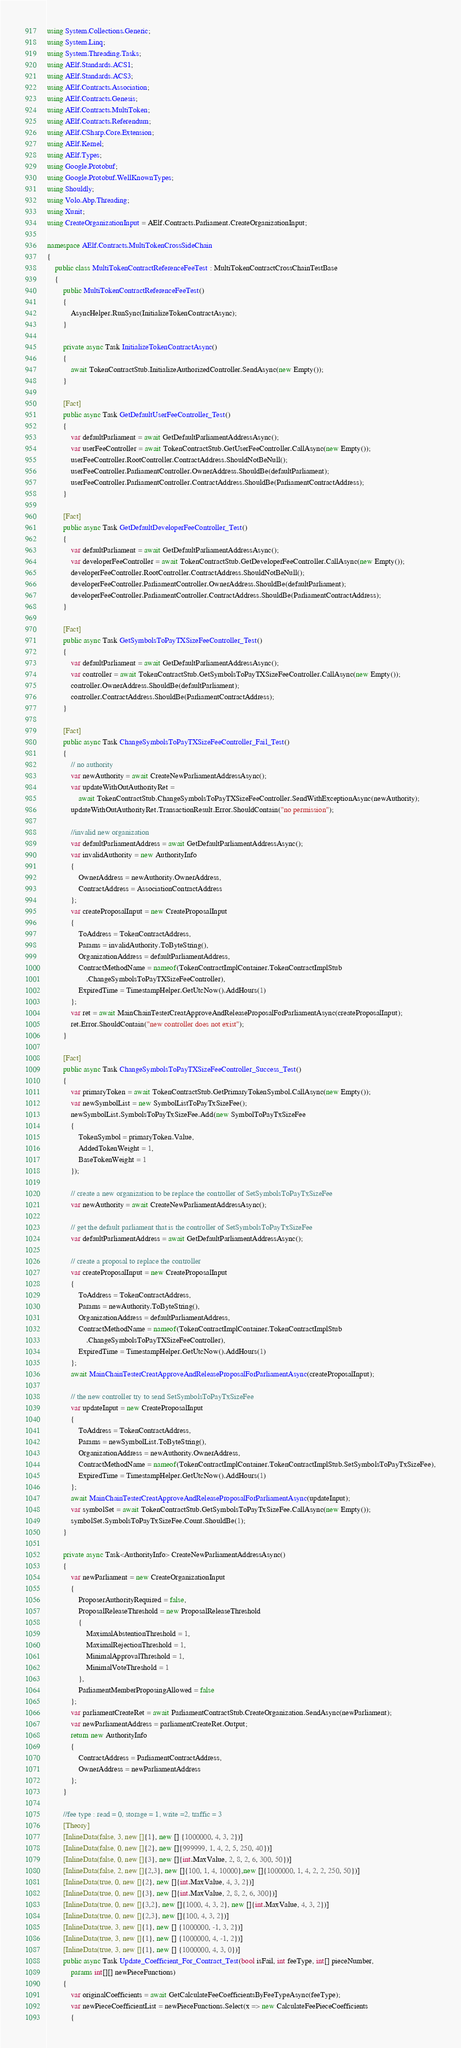Convert code to text. <code><loc_0><loc_0><loc_500><loc_500><_C#_>using System.Collections.Generic;
using System.Linq;
using System.Threading.Tasks;
using AElf.Standards.ACS1;
using AElf.Standards.ACS3;
using AElf.Contracts.Association;
using AElf.Contracts.Genesis;
using AElf.Contracts.MultiToken;
using AElf.Contracts.Referendum;
using AElf.CSharp.Core.Extension;
using AElf.Kernel;
using AElf.Types;
using Google.Protobuf;
using Google.Protobuf.WellKnownTypes;
using Shouldly;
using Volo.Abp.Threading;
using Xunit;
using CreateOrganizationInput = AElf.Contracts.Parliament.CreateOrganizationInput;

namespace AElf.Contracts.MultiTokenCrossSideChain
{
    public class MultiTokenContractReferenceFeeTest : MultiTokenContractCrossChainTestBase
    {
        public MultiTokenContractReferenceFeeTest()
        {
            AsyncHelper.RunSync(InitializeTokenContractAsync);
        }

        private async Task InitializeTokenContractAsync()
        {
            await TokenContractStub.InitializeAuthorizedController.SendAsync(new Empty());
        }
        
        [Fact]
        public async Task GetDefaultUserFeeController_Test()
        {
            var defaultParliament = await GetDefaultParliamentAddressAsync();
            var userFeeController = await TokenContractStub.GetUserFeeController.CallAsync(new Empty());
            userFeeController.RootController.ContractAddress.ShouldNotBeNull();
            userFeeController.ParliamentController.OwnerAddress.ShouldBe(defaultParliament);
            userFeeController.ParliamentController.ContractAddress.ShouldBe(ParliamentContractAddress);
        }
        
        [Fact]
        public async Task GetDefaultDeveloperFeeController_Test()
        {
            var defaultParliament = await GetDefaultParliamentAddressAsync();
            var developerFeeController = await TokenContractStub.GetDeveloperFeeController.CallAsync(new Empty());
            developerFeeController.RootController.ContractAddress.ShouldNotBeNull();
            developerFeeController.ParliamentController.OwnerAddress.ShouldBe(defaultParliament);
            developerFeeController.ParliamentController.ContractAddress.ShouldBe(ParliamentContractAddress);
        }
        
        [Fact]
        public async Task GetSymbolsToPayTXSizeFeeController_Test()
        {
            var defaultParliament = await GetDefaultParliamentAddressAsync();
            var controller = await TokenContractStub.GetSymbolsToPayTXSizeFeeController.CallAsync(new Empty());
            controller.OwnerAddress.ShouldBe(defaultParliament);
            controller.ContractAddress.ShouldBe(ParliamentContractAddress);
        }

        [Fact]
        public async Task ChangeSymbolsToPayTXSizeFeeController_Fail_Test()
        {
            // no authority
            var newAuthority = await CreateNewParliamentAddressAsync();
            var updateWithOutAuthorityRet =
                await TokenContractStub.ChangeSymbolsToPayTXSizeFeeController.SendWithExceptionAsync(newAuthority);
            updateWithOutAuthorityRet.TransactionResult.Error.ShouldContain("no permission");

            //invalid new organization
            var defaultParliamentAddress = await GetDefaultParliamentAddressAsync();
            var invalidAuthority = new AuthorityInfo
            {
                OwnerAddress = newAuthority.OwnerAddress,
                ContractAddress = AssociationContractAddress
            };
            var createProposalInput = new CreateProposalInput
            {
                ToAddress = TokenContractAddress,
                Params = invalidAuthority.ToByteString(),
                OrganizationAddress = defaultParliamentAddress,
                ContractMethodName = nameof(TokenContractImplContainer.TokenContractImplStub
                    .ChangeSymbolsToPayTXSizeFeeController),
                ExpiredTime = TimestampHelper.GetUtcNow().AddHours(1)
            };
            var ret = await MainChainTesterCreatApproveAndReleaseProposalForParliamentAsync(createProposalInput);
            ret.Error.ShouldContain("new controller does not exist");
        }

        [Fact]
        public async Task ChangeSymbolsToPayTXSizeFeeController_Success_Test()
        {
            var primaryToken = await TokenContractStub.GetPrimaryTokenSymbol.CallAsync(new Empty());
            var newSymbolList = new SymbolListToPayTxSizeFee();
            newSymbolList.SymbolsToPayTxSizeFee.Add(new SymbolToPayTxSizeFee
            {
                TokenSymbol = primaryToken.Value,
                AddedTokenWeight = 1,
                BaseTokenWeight = 1
            });
            
            // create a new organization to be replace the controller of SetSymbolsToPayTxSizeFee
            var newAuthority = await CreateNewParliamentAddressAsync();

            // get the default parliament that is the controller of SetSymbolsToPayTxSizeFee
            var defaultParliamentAddress = await GetDefaultParliamentAddressAsync();
            
            // create a proposal to replace the controller
            var createProposalInput = new CreateProposalInput
            {
                ToAddress = TokenContractAddress,
                Params = newAuthority.ToByteString(),
                OrganizationAddress = defaultParliamentAddress,
                ContractMethodName = nameof(TokenContractImplContainer.TokenContractImplStub
                    .ChangeSymbolsToPayTXSizeFeeController),
                ExpiredTime = TimestampHelper.GetUtcNow().AddHours(1)
            };
            await MainChainTesterCreatApproveAndReleaseProposalForParliamentAsync(createProposalInput);
            
            // the new controller try to send SetSymbolsToPayTxSizeFee
            var updateInput = new CreateProposalInput
            {
                ToAddress = TokenContractAddress,
                Params = newSymbolList.ToByteString(),
                OrganizationAddress = newAuthority.OwnerAddress,
                ContractMethodName = nameof(TokenContractImplContainer.TokenContractImplStub.SetSymbolsToPayTxSizeFee),
                ExpiredTime = TimestampHelper.GetUtcNow().AddHours(1)
            };
            await MainChainTesterCreatApproveAndReleaseProposalForParliamentAsync(updateInput);
            var symbolSet = await TokenContractStub.GetSymbolsToPayTxSizeFee.CallAsync(new Empty());
            symbolSet.SymbolsToPayTxSizeFee.Count.ShouldBe(1);
        }
        
        private async Task<AuthorityInfo> CreateNewParliamentAddressAsync()
        {
            var newParliament = new CreateOrganizationInput
            {
                ProposerAuthorityRequired = false,
                ProposalReleaseThreshold = new ProposalReleaseThreshold
                {
                    MaximalAbstentionThreshold = 1,
                    MaximalRejectionThreshold = 1,
                    MinimalApprovalThreshold = 1,
                    MinimalVoteThreshold = 1
                },
                ParliamentMemberProposingAllowed = false
            };
            var parliamentCreateRet = await ParliamentContractStub.CreateOrganization.SendAsync(newParliament);
            var newParliamentAddress = parliamentCreateRet.Output;
            return new AuthorityInfo
            {
                ContractAddress = ParliamentContractAddress,
                OwnerAddress = newParliamentAddress
            };
        }

        //fee type : read = 0, storage = 1, write =2, traffic = 3
        [Theory]
        [InlineData(false, 3, new []{1}, new [] {1000000, 4, 3, 2})]
        [InlineData(false, 0, new []{2}, new []{999999, 1, 4, 2, 5, 250, 40})]
        [InlineData(false, 0, new []{3}, new []{int.MaxValue, 2, 8, 2, 6, 300, 50})]
        [InlineData(false, 2, new []{2,3}, new []{100, 1, 4, 10000},new []{1000000, 1, 4, 2, 2, 250, 50})]
        [InlineData(true, 0, new []{2}, new []{int.MaxValue, 4, 3, 2})]
        [InlineData(true, 0, new []{3}, new []{int.MaxValue, 2, 8, 2, 6, 300})]
        [InlineData(true, 0, new []{3,2}, new []{1000, 4, 3, 2}, new []{int.MaxValue, 4, 3, 2})]
        [InlineData(true, 0, new []{2,3}, new []{100, 4, 3, 2})]
        [InlineData(true, 3, new []{1}, new [] {1000000, -1, 3, 2})]
        [InlineData(true, 3, new []{1}, new [] {1000000, 4, -1, 2})]
        [InlineData(true, 3, new []{1}, new [] {1000000, 4, 3, 0})]
        public async Task Update_Coefficient_For_Contract_Test(bool isFail, int feeType, int[] pieceNumber, 
            params int[][] newPieceFunctions)
        {
            var originalCoefficients = await GetCalculateFeeCoefficientsByFeeTypeAsync(feeType);
            var newPieceCoefficientList = newPieceFunctions.Select(x => new CalculateFeePieceCoefficients
            {</code> 